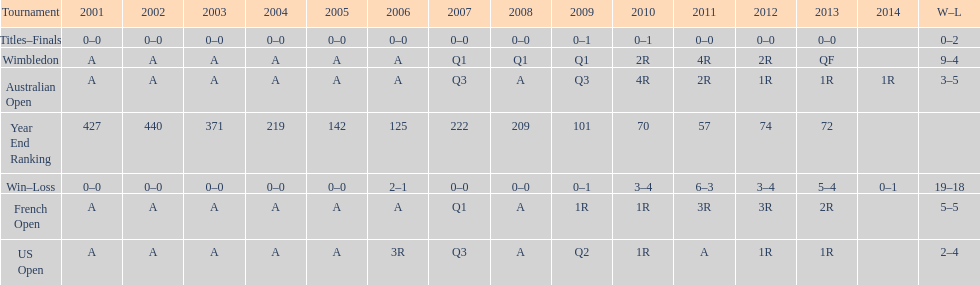How many tournaments had 5 total losses? 2. 